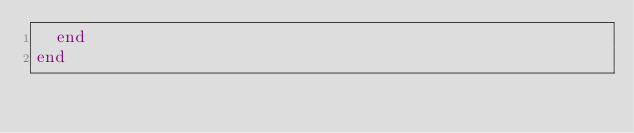Convert code to text. <code><loc_0><loc_0><loc_500><loc_500><_Ruby_>  end
end
</code> 